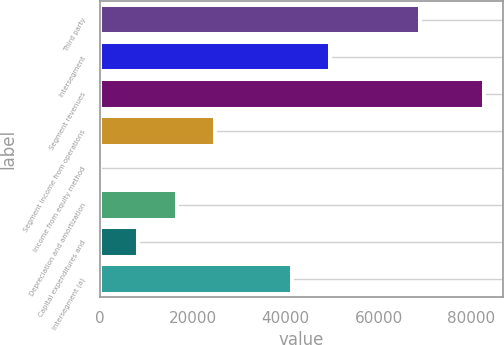Convert chart. <chart><loc_0><loc_0><loc_500><loc_500><bar_chart><fcel>Third party<fcel>Intersegment<fcel>Segment revenues<fcel>Segment income from operations<fcel>Income from equity method<fcel>Depreciation and amortization<fcel>Capital expenditures and<fcel>Intersegment (a)<nl><fcel>68939<fcel>49565.4<fcel>82599<fcel>24790.2<fcel>15<fcel>16531.8<fcel>8273.4<fcel>41307<nl></chart> 